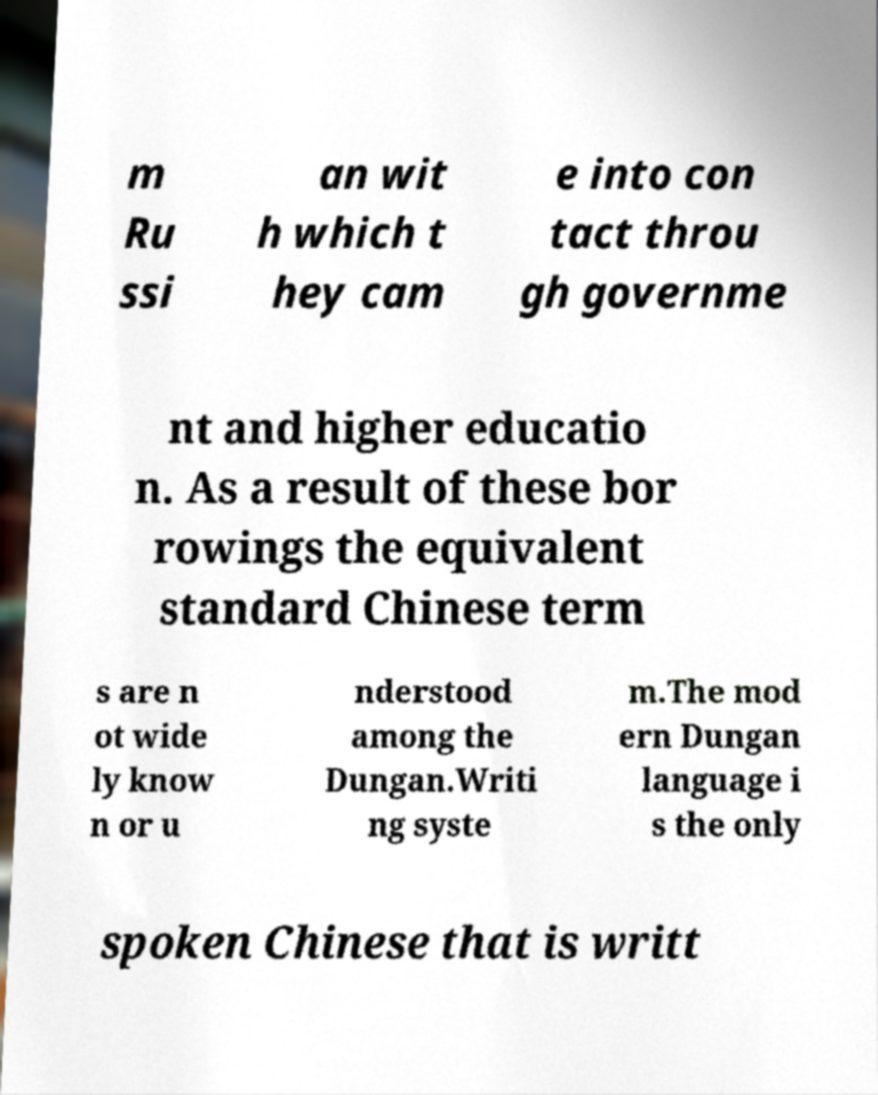I need the written content from this picture converted into text. Can you do that? m Ru ssi an wit h which t hey cam e into con tact throu gh governme nt and higher educatio n. As a result of these bor rowings the equivalent standard Chinese term s are n ot wide ly know n or u nderstood among the Dungan.Writi ng syste m.The mod ern Dungan language i s the only spoken Chinese that is writt 